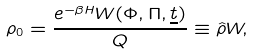<formula> <loc_0><loc_0><loc_500><loc_500>\rho _ { 0 } = \frac { e ^ { - \beta H } W ( \Phi , \Pi , \underline { t } ) } { Q } \equiv \hat { \rho } W ,</formula> 